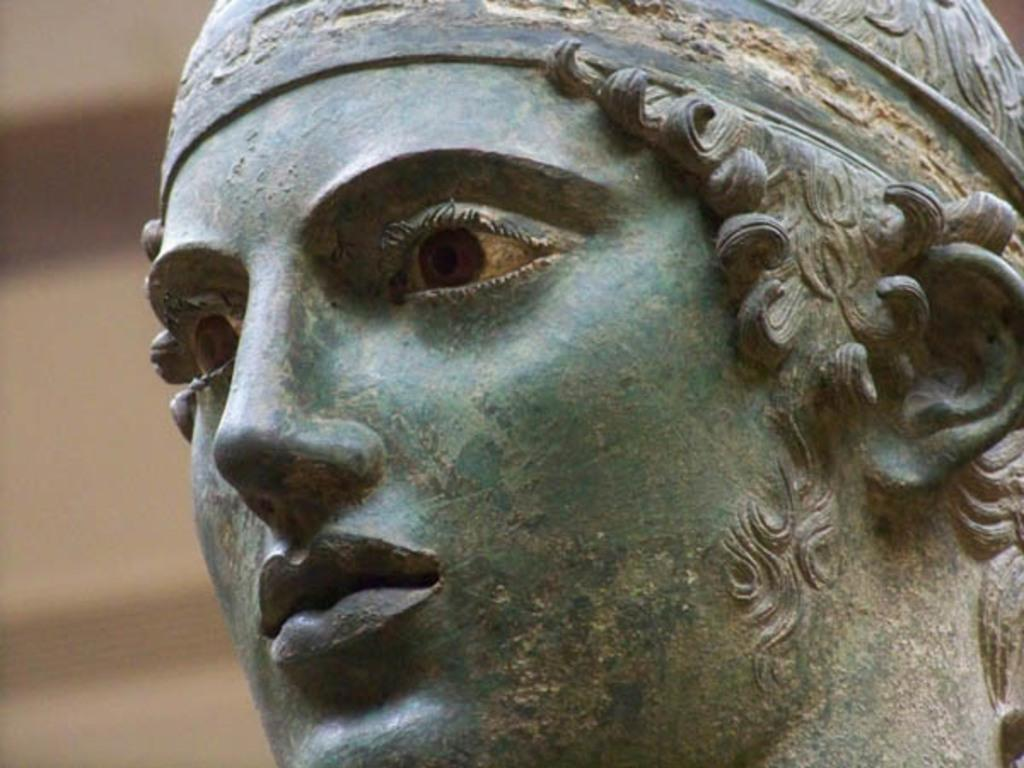What is the main subject of the image? The main subject of the image is a person's sculpture. Can you describe the background of the image? The background of the image is blurred. How many hands are visible in the image? There are no hands visible in the image, as it is a close-up of a person's sculpture. What type of pin can be seen on the army uniform in the image? There is no mention of an army or uniform in the image, as it is a close-up of a person's sculpture. 